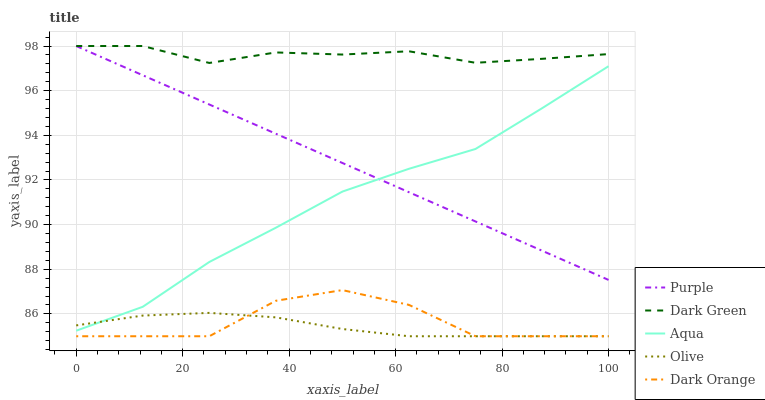Does Olive have the minimum area under the curve?
Answer yes or no. Yes. Does Dark Green have the maximum area under the curve?
Answer yes or no. Yes. Does Aqua have the minimum area under the curve?
Answer yes or no. No. Does Aqua have the maximum area under the curve?
Answer yes or no. No. Is Purple the smoothest?
Answer yes or no. Yes. Is Dark Orange the roughest?
Answer yes or no. Yes. Is Olive the smoothest?
Answer yes or no. No. Is Olive the roughest?
Answer yes or no. No. Does Aqua have the lowest value?
Answer yes or no. No. Does Dark Green have the highest value?
Answer yes or no. Yes. Does Aqua have the highest value?
Answer yes or no. No. Is Olive less than Purple?
Answer yes or no. Yes. Is Purple greater than Dark Orange?
Answer yes or no. Yes. Does Olive intersect Purple?
Answer yes or no. No. 